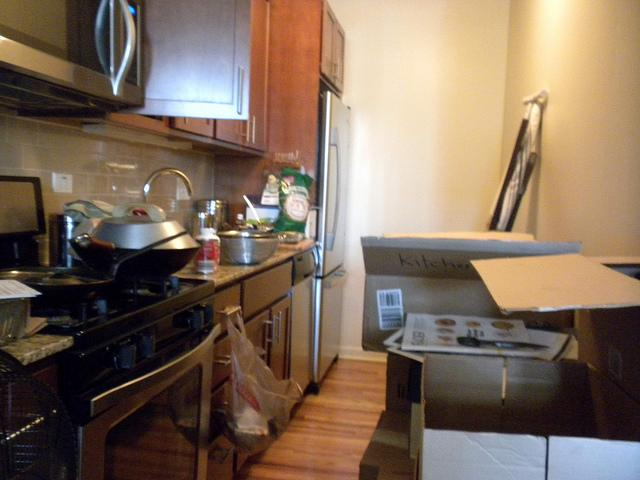What does the cardboard box tell us about this situation?

Choices:
A) shops amazon
B) likes coffee
C) wrong room
D) moving in moving in 